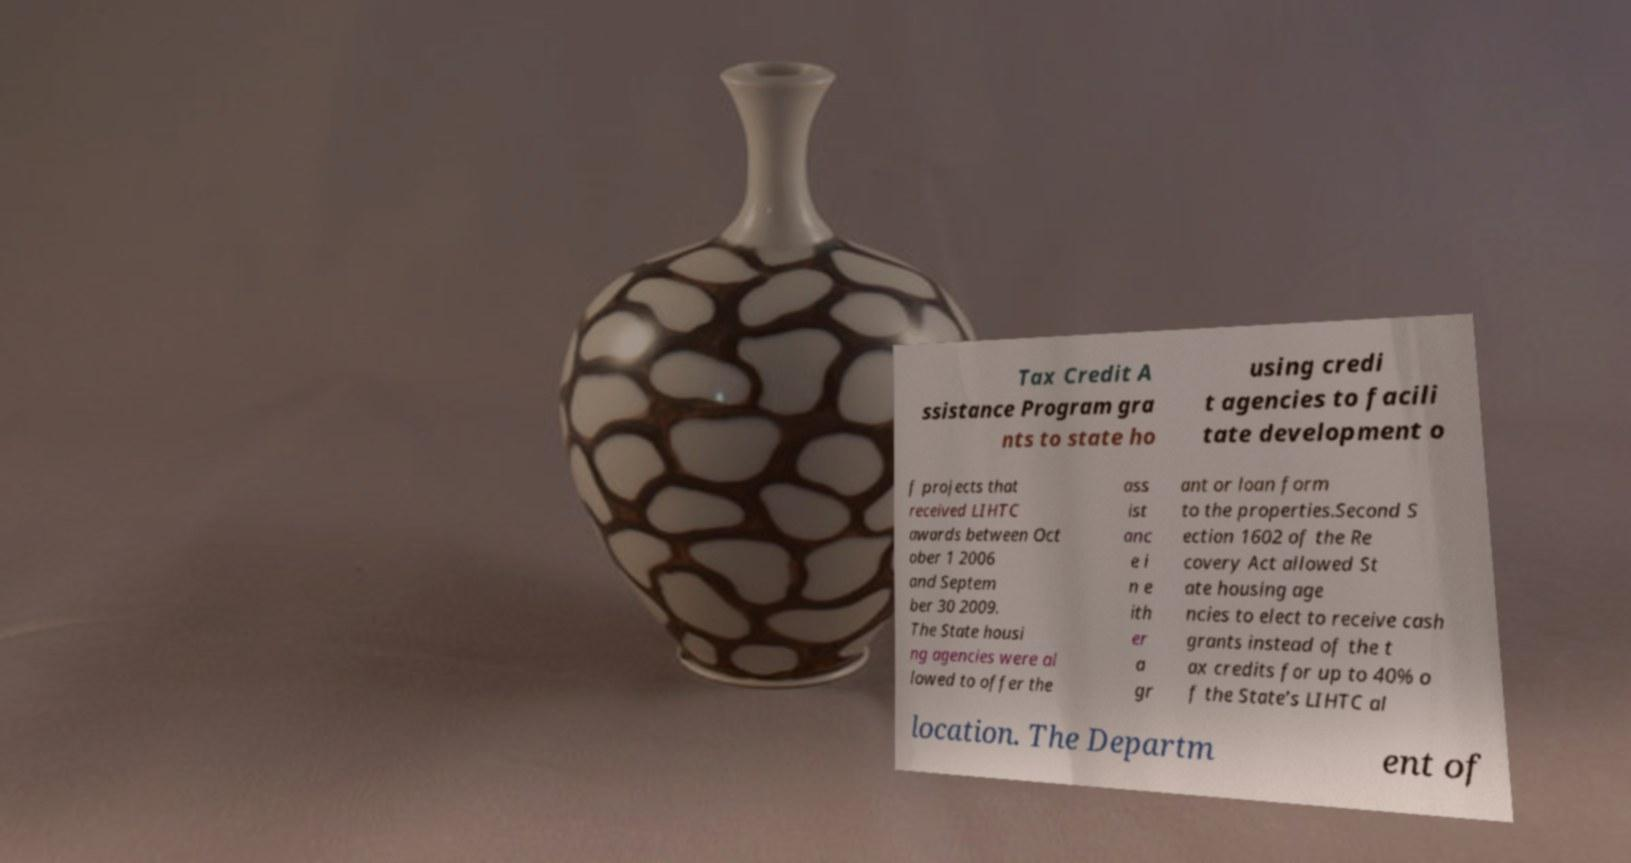What messages or text are displayed in this image? I need them in a readable, typed format. Tax Credit A ssistance Program gra nts to state ho using credi t agencies to facili tate development o f projects that received LIHTC awards between Oct ober 1 2006 and Septem ber 30 2009. The State housi ng agencies were al lowed to offer the ass ist anc e i n e ith er a gr ant or loan form to the properties.Second S ection 1602 of the Re covery Act allowed St ate housing age ncies to elect to receive cash grants instead of the t ax credits for up to 40% o f the State’s LIHTC al location. The Departm ent of 